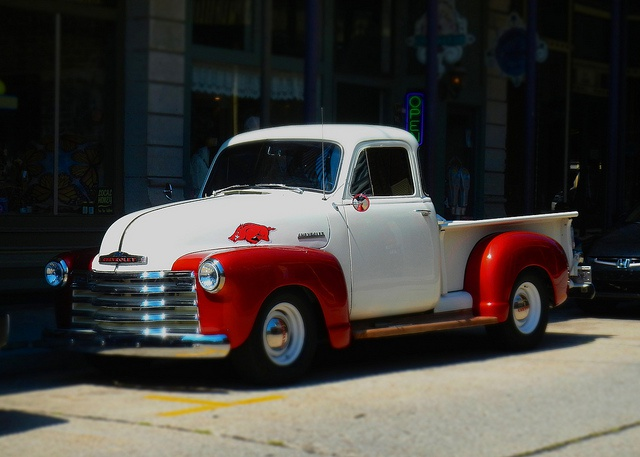Describe the objects in this image and their specific colors. I can see a truck in black, lightgray, gray, and maroon tones in this image. 